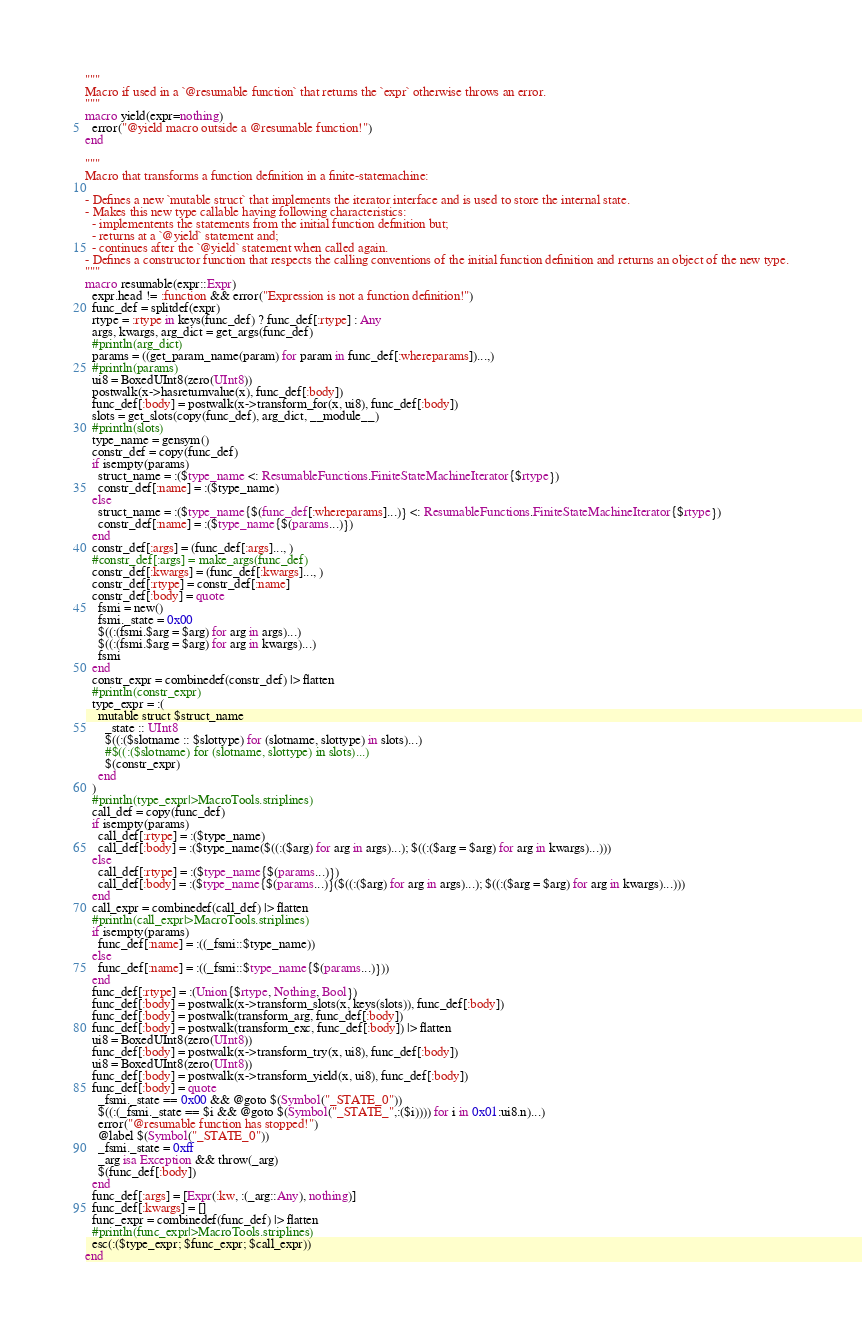<code> <loc_0><loc_0><loc_500><loc_500><_Julia_>"""
Macro if used in a `@resumable function` that returns the `expr` otherwise throws an error.
"""
macro yield(expr=nothing)
  error("@yield macro outside a @resumable function!")
end

"""
Macro that transforms a function definition in a finite-statemachine:

- Defines a new `mutable struct` that implements the iterator interface and is used to store the internal state.
- Makes this new type callable having following characteristics:
  - implementents the statements from the initial function definition but;
  - returns at a `@yield` statement and;
  - continues after the `@yield` statement when called again.
- Defines a constructor function that respects the calling conventions of the initial function definition and returns an object of the new type.
"""
macro resumable(expr::Expr)
  expr.head != :function && error("Expression is not a function definition!")
  func_def = splitdef(expr)
  rtype = :rtype in keys(func_def) ? func_def[:rtype] : Any
  args, kwargs, arg_dict = get_args(func_def)
  #println(arg_dict)
  params = ((get_param_name(param) for param in func_def[:whereparams])...,)
  #println(params)
  ui8 = BoxedUInt8(zero(UInt8))
  postwalk(x->hasreturnvalue(x), func_def[:body])
  func_def[:body] = postwalk(x->transform_for(x, ui8), func_def[:body])
  slots = get_slots(copy(func_def), arg_dict, __module__)
  #println(slots)
  type_name = gensym()
  constr_def = copy(func_def)
  if isempty(params)
    struct_name = :($type_name <: ResumableFunctions.FiniteStateMachineIterator{$rtype})
    constr_def[:name] = :($type_name)
  else
    struct_name = :($type_name{$(func_def[:whereparams]...)} <: ResumableFunctions.FiniteStateMachineIterator{$rtype})
    constr_def[:name] = :($type_name{$(params...)})
  end
  constr_def[:args] = (func_def[:args]..., )
  #constr_def[:args] = make_args(func_def)
  constr_def[:kwargs] = (func_def[:kwargs]..., )
  constr_def[:rtype] = constr_def[:name]
  constr_def[:body] = quote
    fsmi = new()
    fsmi._state = 0x00
    $((:(fsmi.$arg = $arg) for arg in args)...)
    $((:(fsmi.$arg = $arg) for arg in kwargs)...)
    fsmi
  end
  constr_expr = combinedef(constr_def) |> flatten
  #println(constr_expr)
  type_expr = :(
    mutable struct $struct_name
      _state :: UInt8
      $((:($slotname :: $slottype) for (slotname, slottype) in slots)...)
      #$((:($slotname) for (slotname, slottype) in slots)...)
      $(constr_expr)
    end
  )
  #println(type_expr|>MacroTools.striplines)
  call_def = copy(func_def)
  if isempty(params)
    call_def[:rtype] = :($type_name)
    call_def[:body] = :($type_name($((:($arg) for arg in args)...); $((:($arg = $arg) for arg in kwargs)...)))
  else
    call_def[:rtype] = :($type_name{$(params...)})
    call_def[:body] = :($type_name{$(params...)}($((:($arg) for arg in args)...); $((:($arg = $arg) for arg in kwargs)...)))
  end
  call_expr = combinedef(call_def) |> flatten
  #println(call_expr|>MacroTools.striplines)
  if isempty(params)
    func_def[:name] = :((_fsmi::$type_name))
  else
    func_def[:name] = :((_fsmi::$type_name{$(params...)}))
  end
  func_def[:rtype] = :(Union{$rtype, Nothing, Bool})
  func_def[:body] = postwalk(x->transform_slots(x, keys(slots)), func_def[:body])
  func_def[:body] = postwalk(transform_arg, func_def[:body])
  func_def[:body] = postwalk(transform_exc, func_def[:body]) |> flatten
  ui8 = BoxedUInt8(zero(UInt8))
  func_def[:body] = postwalk(x->transform_try(x, ui8), func_def[:body])
  ui8 = BoxedUInt8(zero(UInt8))
  func_def[:body] = postwalk(x->transform_yield(x, ui8), func_def[:body])
  func_def[:body] = quote
    _fsmi._state == 0x00 && @goto $(Symbol("_STATE_0"))
    $((:(_fsmi._state == $i && @goto $(Symbol("_STATE_",:($i)))) for i in 0x01:ui8.n)...)
    error("@resumable function has stopped!")
    @label $(Symbol("_STATE_0"))
    _fsmi._state = 0xff
    _arg isa Exception && throw(_arg)
    $(func_def[:body])
  end
  func_def[:args] = [Expr(:kw, :(_arg::Any), nothing)]
  func_def[:kwargs] = []
  func_expr = combinedef(func_def) |> flatten
  #println(func_expr|>MacroTools.striplines)
  esc(:($type_expr; $func_expr; $call_expr))
end
</code> 